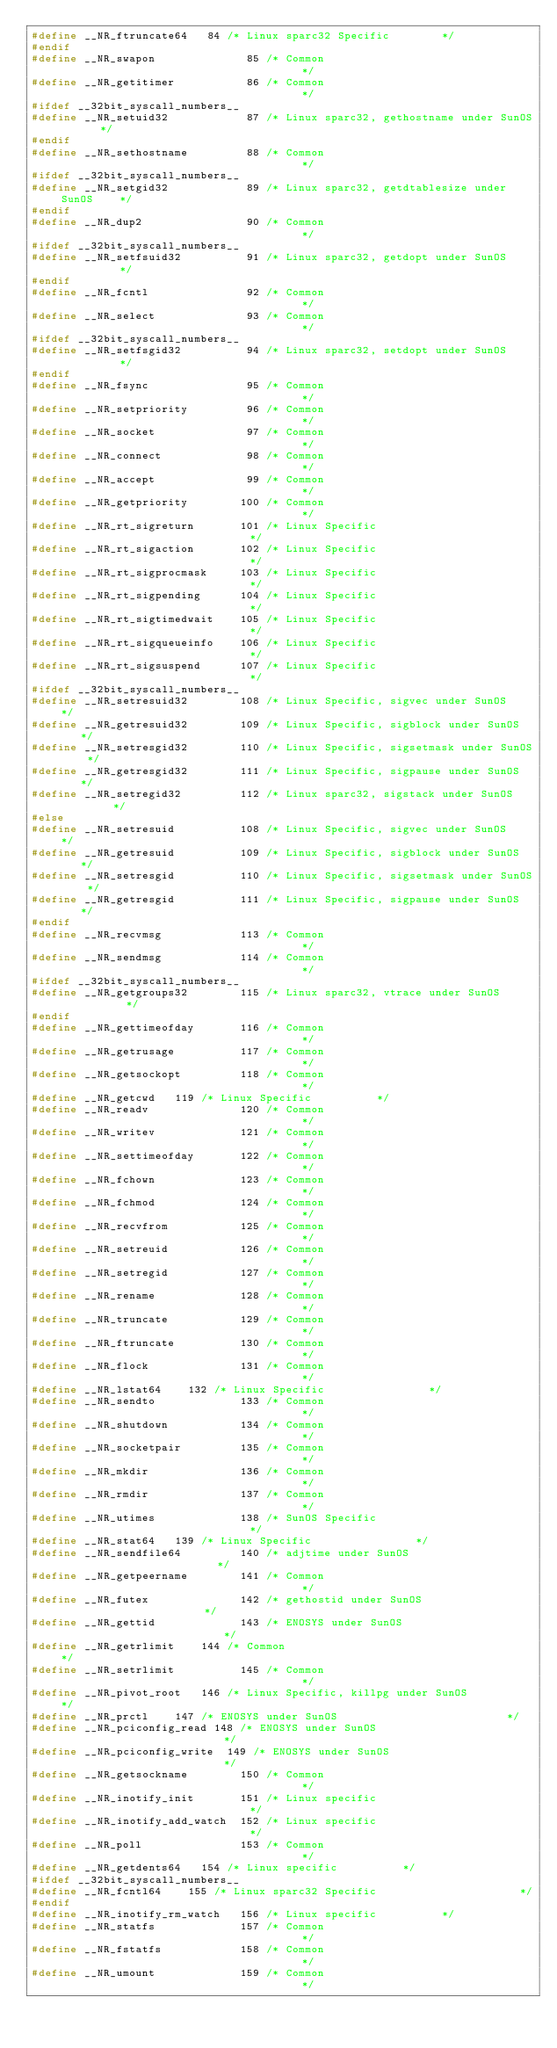Convert code to text. <code><loc_0><loc_0><loc_500><loc_500><_C_>#define __NR_ftruncate64	 84 /* Linux sparc32 Specific			   */
#endif
#define __NR_swapon              85 /* Common                                      */
#define __NR_getitimer           86 /* Common                                      */
#ifdef __32bit_syscall_numbers__
#define __NR_setuid32            87 /* Linux sparc32, gethostname under SunOS      */
#endif
#define __NR_sethostname         88 /* Common                                      */
#ifdef __32bit_syscall_numbers__
#define __NR_setgid32            89 /* Linux sparc32, getdtablesize under SunOS    */
#endif
#define __NR_dup2                90 /* Common                                      */
#ifdef __32bit_syscall_numbers__
#define __NR_setfsuid32          91 /* Linux sparc32, getdopt under SunOS          */
#endif
#define __NR_fcntl               92 /* Common                                      */
#define __NR_select              93 /* Common                                      */
#ifdef __32bit_syscall_numbers__
#define __NR_setfsgid32          94 /* Linux sparc32, setdopt under SunOS          */
#endif
#define __NR_fsync               95 /* Common                                      */
#define __NR_setpriority         96 /* Common                                      */
#define __NR_socket              97 /* Common                                      */
#define __NR_connect             98 /* Common                                      */
#define __NR_accept              99 /* Common                                      */
#define __NR_getpriority        100 /* Common                                      */
#define __NR_rt_sigreturn       101 /* Linux Specific                              */
#define __NR_rt_sigaction       102 /* Linux Specific                              */
#define __NR_rt_sigprocmask     103 /* Linux Specific                              */
#define __NR_rt_sigpending      104 /* Linux Specific                              */
#define __NR_rt_sigtimedwait    105 /* Linux Specific                              */
#define __NR_rt_sigqueueinfo    106 /* Linux Specific                              */
#define __NR_rt_sigsuspend      107 /* Linux Specific                              */
#ifdef __32bit_syscall_numbers__
#define __NR_setresuid32        108 /* Linux Specific, sigvec under SunOS	   */
#define __NR_getresuid32        109 /* Linux Specific, sigblock under SunOS	   */
#define __NR_setresgid32        110 /* Linux Specific, sigsetmask under SunOS	   */
#define __NR_getresgid32        111 /* Linux Specific, sigpause under SunOS	   */
#define __NR_setregid32         112 /* Linux sparc32, sigstack under SunOS         */
#else
#define __NR_setresuid          108 /* Linux Specific, sigvec under SunOS	   */
#define __NR_getresuid          109 /* Linux Specific, sigblock under SunOS	   */
#define __NR_setresgid          110 /* Linux Specific, sigsetmask under SunOS	   */
#define __NR_getresgid          111 /* Linux Specific, sigpause under SunOS	   */
#endif
#define __NR_recvmsg            113 /* Common                                      */
#define __NR_sendmsg            114 /* Common                                      */
#ifdef __32bit_syscall_numbers__
#define __NR_getgroups32        115 /* Linux sparc32, vtrace under SunOS           */
#endif
#define __NR_gettimeofday       116 /* Common                                      */
#define __NR_getrusage          117 /* Common                                      */
#define __NR_getsockopt         118 /* Common                                      */
#define __NR_getcwd		119 /* Linux Specific				   */
#define __NR_readv              120 /* Common                                      */
#define __NR_writev             121 /* Common                                      */
#define __NR_settimeofday       122 /* Common                                      */
#define __NR_fchown             123 /* Common                                      */
#define __NR_fchmod             124 /* Common                                      */
#define __NR_recvfrom           125 /* Common                                      */
#define __NR_setreuid           126 /* Common                                      */
#define __NR_setregid           127 /* Common                                      */
#define __NR_rename             128 /* Common                                      */
#define __NR_truncate           129 /* Common                                      */
#define __NR_ftruncate          130 /* Common                                      */
#define __NR_flock              131 /* Common                                      */
#define __NR_lstat64		132 /* Linux Specific			           */
#define __NR_sendto             133 /* Common                                      */
#define __NR_shutdown           134 /* Common                                      */
#define __NR_socketpair         135 /* Common                                      */
#define __NR_mkdir              136 /* Common                                      */
#define __NR_rmdir              137 /* Common                                      */
#define __NR_utimes             138 /* SunOS Specific                              */
#define __NR_stat64		139 /* Linux Specific			           */
#define __NR_sendfile64         140 /* adjtime under SunOS                         */
#define __NR_getpeername        141 /* Common                                      */
#define __NR_futex              142 /* gethostid under SunOS                       */
#define __NR_gettid             143 /* ENOSYS under SunOS                          */
#define __NR_getrlimit		144 /* Common                                      */
#define __NR_setrlimit          145 /* Common                                      */
#define __NR_pivot_root		146 /* Linux Specific, killpg under SunOS          */
#define __NR_prctl		147 /* ENOSYS under SunOS                          */
#define __NR_pciconfig_read	148 /* ENOSYS under SunOS                          */
#define __NR_pciconfig_write	149 /* ENOSYS under SunOS                          */
#define __NR_getsockname        150 /* Common                                      */
#define __NR_inotify_init       151 /* Linux specific                              */
#define __NR_inotify_add_watch  152 /* Linux specific                              */
#define __NR_poll               153 /* Common                                      */
#define __NR_getdents64		154 /* Linux specific				   */
#ifdef __32bit_syscall_numbers__
#define __NR_fcntl64		155 /* Linux sparc32 Specific                      */
#endif
#define __NR_inotify_rm_watch   156 /* Linux specific				   */
#define __NR_statfs             157 /* Common                                      */
#define __NR_fstatfs            158 /* Common                                      */
#define __NR_umount             159 /* Common                                      */</code> 